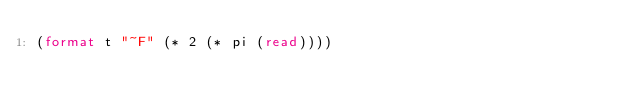<code> <loc_0><loc_0><loc_500><loc_500><_Lisp_>(format t "~F" (* 2 (* pi (read))))</code> 